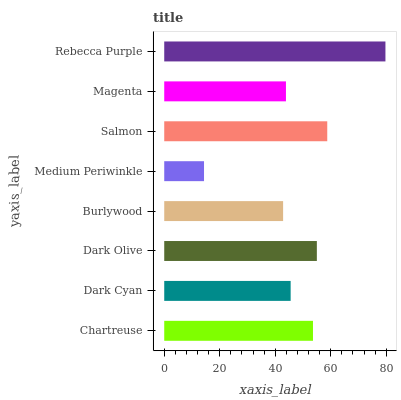Is Medium Periwinkle the minimum?
Answer yes or no. Yes. Is Rebecca Purple the maximum?
Answer yes or no. Yes. Is Dark Cyan the minimum?
Answer yes or no. No. Is Dark Cyan the maximum?
Answer yes or no. No. Is Chartreuse greater than Dark Cyan?
Answer yes or no. Yes. Is Dark Cyan less than Chartreuse?
Answer yes or no. Yes. Is Dark Cyan greater than Chartreuse?
Answer yes or no. No. Is Chartreuse less than Dark Cyan?
Answer yes or no. No. Is Chartreuse the high median?
Answer yes or no. Yes. Is Dark Cyan the low median?
Answer yes or no. Yes. Is Medium Periwinkle the high median?
Answer yes or no. No. Is Dark Olive the low median?
Answer yes or no. No. 